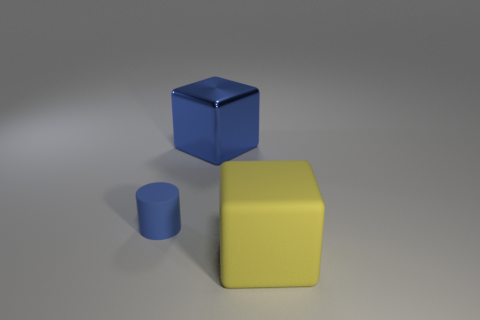Can you describe the lighting and shadowing in the scene? The lighting in the scene seems to come from a point above and to the left, as indicated by the shadows cast. The shadows are reasonably soft, which could suggest a light source that is not overly harsh or is possibly diffused, allowing for gentle contrasts and subtle details to be seen on the surfaces of the objects. 